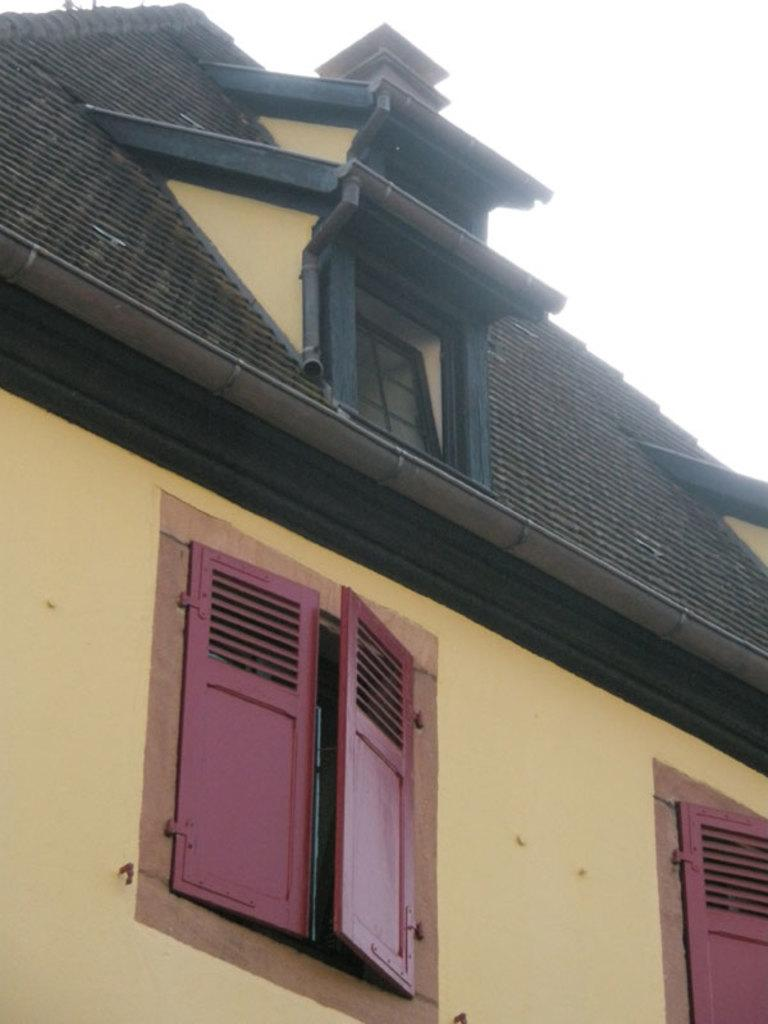What type of structure is visible in the image? There is a house in the image. What colors are used in the house's color scheme? The house has a yellow and black color scheme. What is the color of the windows on the house? The windows of the house are pink in color. What type of metal is used to make the soap in the image? There is no soap present in the image, so it is not possible to determine what type of metal might be used to make it. 